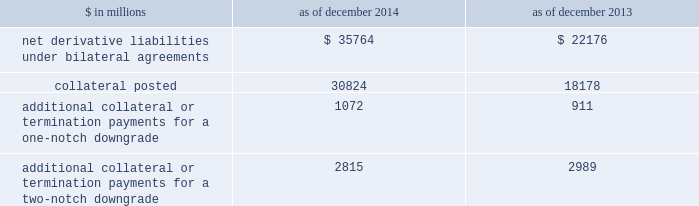Notes to consolidated financial statements derivatives with credit-related contingent features certain of the firm 2019s derivatives have been transacted under bilateral agreements with counterparties who may require the firm to post collateral or terminate the transactions based on changes in the firm 2019s credit ratings .
The firm assesses the impact of these bilateral agreements by determining the collateral or termination payments that would occur assuming a downgrade by all rating agencies .
A downgrade by any one rating agency , depending on the agency 2019s relative ratings of the firm at the time of the downgrade , may have an impact which is comparable to the impact of a downgrade by all rating agencies .
The table below presents the aggregate fair value of net derivative liabilities under such agreements ( excluding application of collateral posted to reduce these liabilities ) , the related aggregate fair value of the assets posted as collateral , and the additional collateral or termination payments that could have been called at the reporting date by counterparties in the event of a one-notch and two-notch downgrade in the firm 2019s credit ratings. .
Additional collateral or termination payments for a one-notch downgrade 1072 911 additional collateral or termination payments for a two-notch downgrade 2815 2989 credit derivatives the firm enters into a broad array of credit derivatives in locations around the world to facilitate client transactions and to manage the credit risk associated with market- making and investing and lending activities .
Credit derivatives are actively managed based on the firm 2019s net risk position .
Credit derivatives are individually negotiated contracts and can have various settlement and payment conventions .
Credit events include failure to pay , bankruptcy , acceleration of indebtedness , restructuring , repudiation and dissolution of the reference entity .
Credit default swaps .
Single-name credit default swaps protect the buyer against the loss of principal on one or more bonds , loans or mortgages ( reference obligations ) in the event the issuer ( reference entity ) of the reference obligations suffers a credit event .
The buyer of protection pays an initial or periodic premium to the seller and receives protection for the period of the contract .
If there is no credit event , as defined in the contract , the seller of protection makes no payments to the buyer of protection .
However , if a credit event occurs , the seller of protection is required to make a payment to the buyer of protection , which is calculated in accordance with the terms of the contract .
Credit indices , baskets and tranches .
Credit derivatives may reference a basket of single-name credit default swaps or a broad-based index .
If a credit event occurs in one of the underlying reference obligations , the protection seller pays the protection buyer .
The payment is typically a pro-rata portion of the transaction 2019s total notional amount based on the underlying defaulted reference obligation .
In certain transactions , the credit risk of a basket or index is separated into various portions ( tranches ) , each having different levels of subordination .
The most junior tranches cover initial defaults and once losses exceed the notional amount of these junior tranches , any excess loss is covered by the next most senior tranche in the capital structure .
Total return swaps .
A total return swap transfers the risks relating to economic performance of a reference obligation from the protection buyer to the protection seller .
Typically , the protection buyer receives from the protection seller a floating rate of interest and protection against any reduction in fair value of the reference obligation , and in return the protection seller receives the cash flows associated with the reference obligation , plus any increase in the fair value of the reference obligation .
132 goldman sachs 2014 annual report .
What was the percentage change in collateral posted between 2013 and 2014? 
Rationale: collateral posted grew substantially more than the underlying agreements .
Computations: ((30824 - 18178) / 18178)
Answer: 0.69568. 